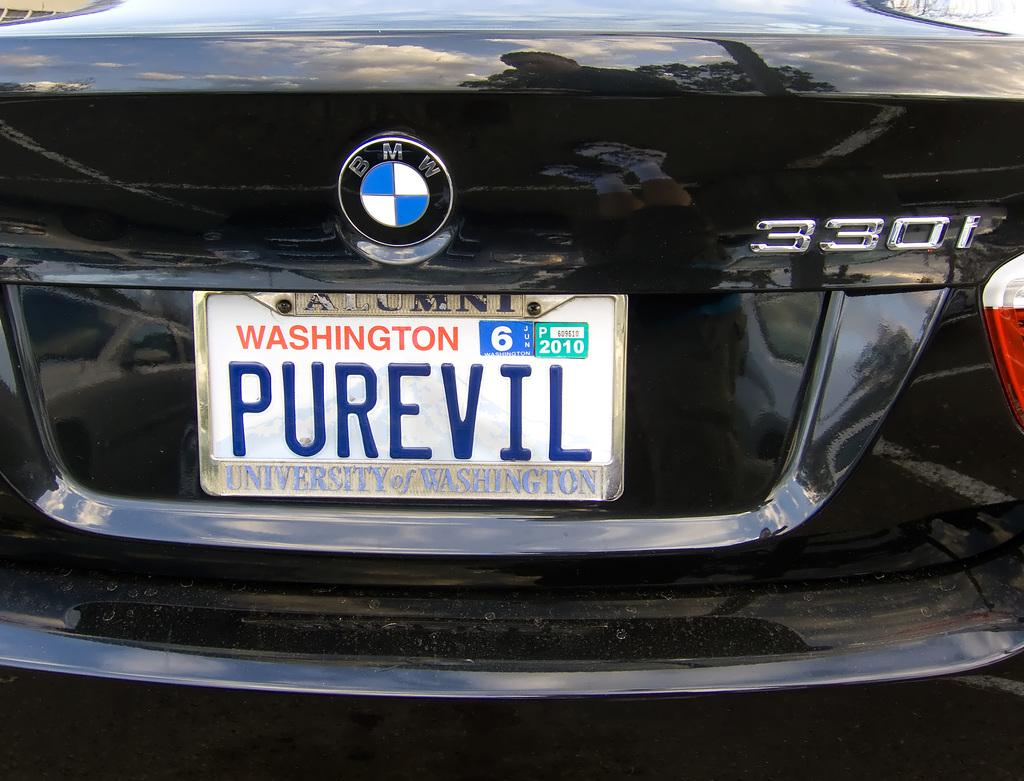<image>
Relay a brief, clear account of the picture shown. Car with a white license plate which says "PUREVIL". 